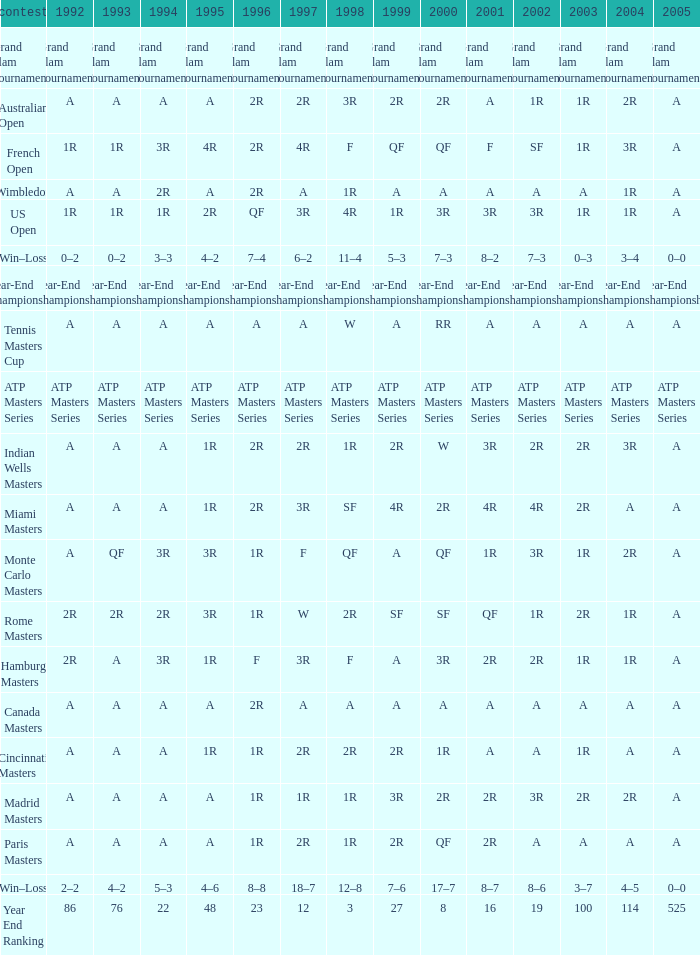What is 1998, when 1997 is "3R", and when 1992 is "A"? SF. 